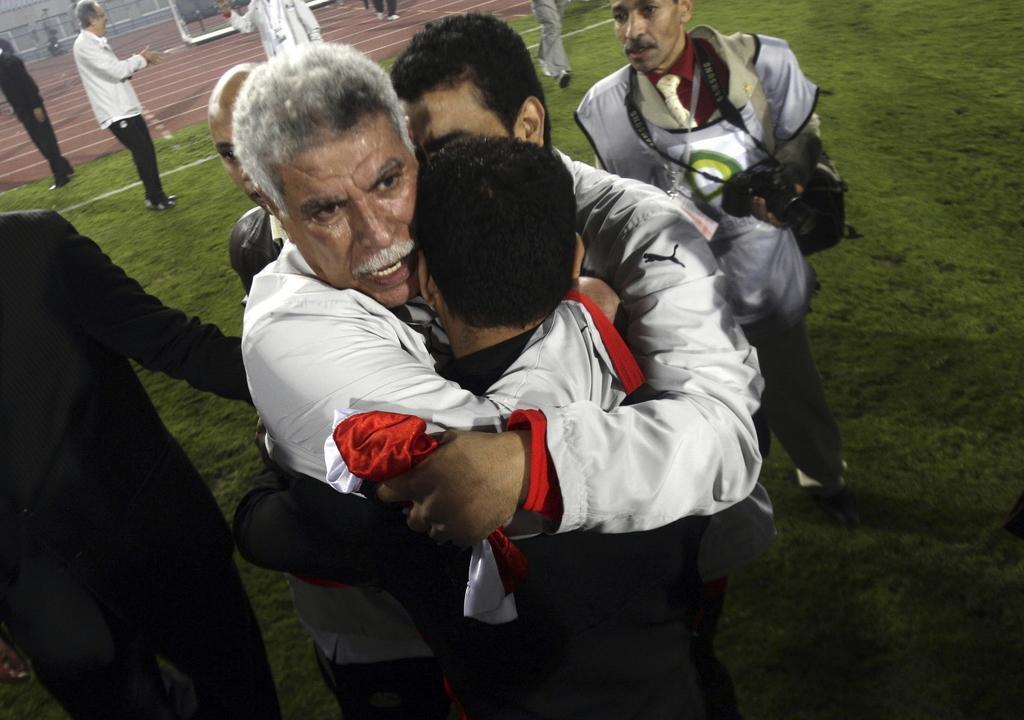How would you summarize this image in a sentence or two? In this picture we can see group of people, few are standing on the grass and few are walking, in the background we can find metal rods. 